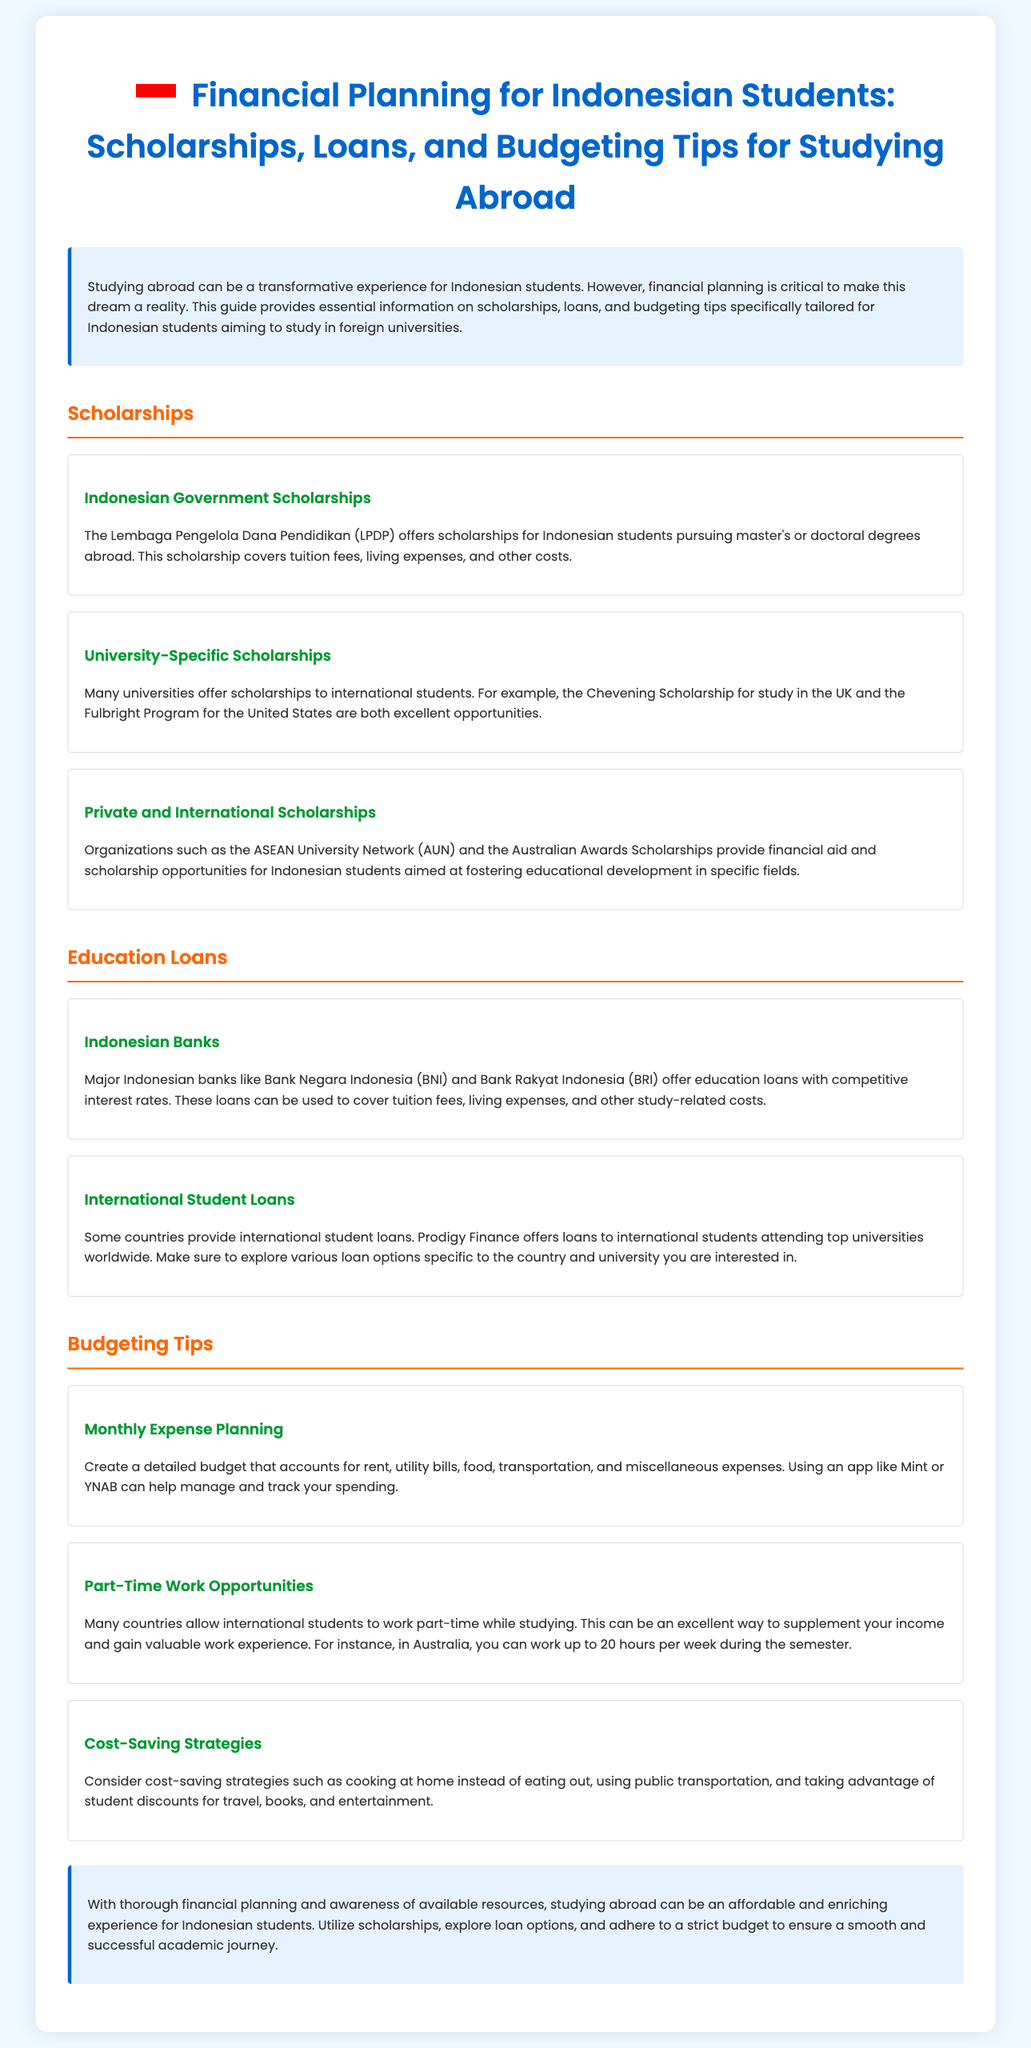What scholarships does the Indonesian government offer? The document states that the Lembaga Pengelola Dana Pendidikan (LPDP) offers scholarships for Indonesian students pursuing master's or doctoral degrees abroad.
Answer: LPDP What does the Chevening Scholarship provide? The document mentions that the Chevening Scholarship is an opportunity for study in the UK, specifically targeted at international students.
Answer: Study in the UK What is the maximum working hours for international students in Australia during the semester? The document notes that international students in Australia can work up to 20 hours per week during the semester.
Answer: 20 hours Which Indonesian banks offer education loans? The document lists major Indonesian banks like Bank Negara Indonesia (BNI) and Bank Rakyat Indonesia (BRI) that provide education loans.
Answer: BNI and BRI What is one suggested app for budgeting? The document recommends using apps like Mint or YNAB to help manage and track spending.
Answer: Mint What are two strategies mentioned for cost-saving? The document suggests cooking at home and using public transportation as cost-saving strategies for students.
Answer: Cooking at home, public transportation How does the document describe studying abroad for Indonesian students? The overall sentiment in the document indicates that studying abroad can be a transformative experience but emphasizes the need for financial planning.
Answer: Transformative experience Which organization offers international scholarships specifically for Indonesian students? The document mentions the ASEAN University Network (AUN) as an organization that provides financial aid and scholarship opportunities.
Answer: ASEAN University Network 